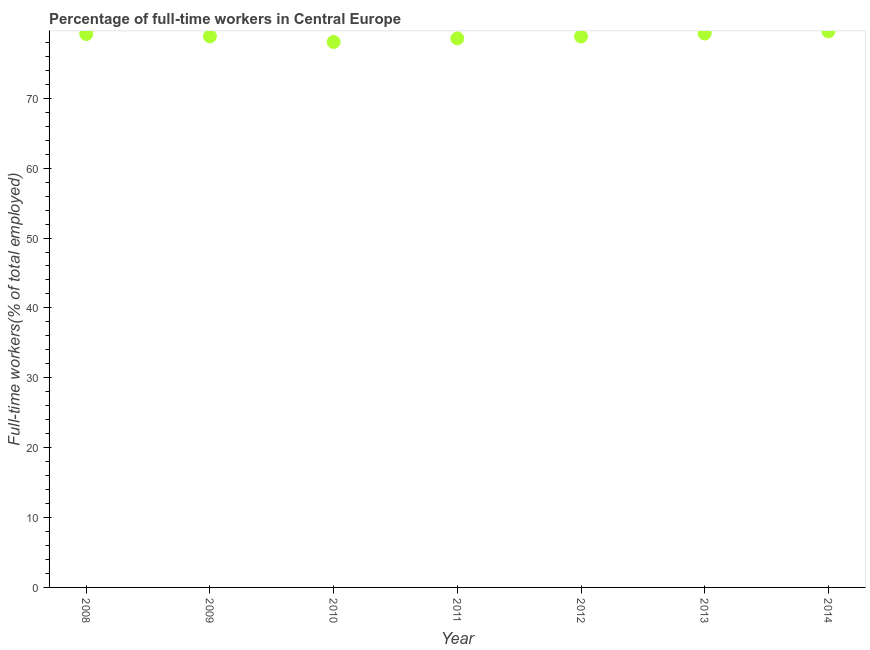What is the percentage of full-time workers in 2008?
Offer a terse response. 79.2. Across all years, what is the maximum percentage of full-time workers?
Your response must be concise. 79.58. Across all years, what is the minimum percentage of full-time workers?
Provide a succinct answer. 78.06. In which year was the percentage of full-time workers maximum?
Provide a succinct answer. 2014. In which year was the percentage of full-time workers minimum?
Your response must be concise. 2010. What is the sum of the percentage of full-time workers?
Ensure brevity in your answer.  552.38. What is the difference between the percentage of full-time workers in 2008 and 2011?
Offer a very short reply. 0.62. What is the average percentage of full-time workers per year?
Provide a short and direct response. 78.91. What is the median percentage of full-time workers?
Offer a terse response. 78.86. In how many years, is the percentage of full-time workers greater than 50 %?
Offer a very short reply. 7. Do a majority of the years between 2011 and 2014 (inclusive) have percentage of full-time workers greater than 74 %?
Offer a terse response. Yes. What is the ratio of the percentage of full-time workers in 2009 to that in 2012?
Provide a short and direct response. 1. Is the difference between the percentage of full-time workers in 2011 and 2012 greater than the difference between any two years?
Offer a terse response. No. What is the difference between the highest and the second highest percentage of full-time workers?
Your answer should be very brief. 0.31. Is the sum of the percentage of full-time workers in 2008 and 2014 greater than the maximum percentage of full-time workers across all years?
Provide a succinct answer. Yes. What is the difference between the highest and the lowest percentage of full-time workers?
Your response must be concise. 1.52. Does the percentage of full-time workers monotonically increase over the years?
Ensure brevity in your answer.  No. What is the difference between two consecutive major ticks on the Y-axis?
Give a very brief answer. 10. Are the values on the major ticks of Y-axis written in scientific E-notation?
Make the answer very short. No. Does the graph contain any zero values?
Provide a succinct answer. No. Does the graph contain grids?
Ensure brevity in your answer.  No. What is the title of the graph?
Provide a succinct answer. Percentage of full-time workers in Central Europe. What is the label or title of the Y-axis?
Ensure brevity in your answer.  Full-time workers(% of total employed). What is the Full-time workers(% of total employed) in 2008?
Your answer should be compact. 79.2. What is the Full-time workers(% of total employed) in 2009?
Provide a succinct answer. 78.86. What is the Full-time workers(% of total employed) in 2010?
Provide a short and direct response. 78.06. What is the Full-time workers(% of total employed) in 2011?
Your answer should be compact. 78.58. What is the Full-time workers(% of total employed) in 2012?
Ensure brevity in your answer.  78.84. What is the Full-time workers(% of total employed) in 2013?
Make the answer very short. 79.27. What is the Full-time workers(% of total employed) in 2014?
Make the answer very short. 79.58. What is the difference between the Full-time workers(% of total employed) in 2008 and 2009?
Provide a succinct answer. 0.34. What is the difference between the Full-time workers(% of total employed) in 2008 and 2010?
Ensure brevity in your answer.  1.14. What is the difference between the Full-time workers(% of total employed) in 2008 and 2011?
Offer a terse response. 0.62. What is the difference between the Full-time workers(% of total employed) in 2008 and 2012?
Provide a short and direct response. 0.36. What is the difference between the Full-time workers(% of total employed) in 2008 and 2013?
Offer a very short reply. -0.07. What is the difference between the Full-time workers(% of total employed) in 2008 and 2014?
Give a very brief answer. -0.38. What is the difference between the Full-time workers(% of total employed) in 2009 and 2010?
Your response must be concise. 0.8. What is the difference between the Full-time workers(% of total employed) in 2009 and 2011?
Ensure brevity in your answer.  0.28. What is the difference between the Full-time workers(% of total employed) in 2009 and 2012?
Keep it short and to the point. 0.02. What is the difference between the Full-time workers(% of total employed) in 2009 and 2013?
Ensure brevity in your answer.  -0.41. What is the difference between the Full-time workers(% of total employed) in 2009 and 2014?
Keep it short and to the point. -0.72. What is the difference between the Full-time workers(% of total employed) in 2010 and 2011?
Provide a short and direct response. -0.52. What is the difference between the Full-time workers(% of total employed) in 2010 and 2012?
Your answer should be very brief. -0.78. What is the difference between the Full-time workers(% of total employed) in 2010 and 2013?
Your answer should be compact. -1.21. What is the difference between the Full-time workers(% of total employed) in 2010 and 2014?
Make the answer very short. -1.52. What is the difference between the Full-time workers(% of total employed) in 2011 and 2012?
Give a very brief answer. -0.26. What is the difference between the Full-time workers(% of total employed) in 2011 and 2013?
Keep it short and to the point. -0.69. What is the difference between the Full-time workers(% of total employed) in 2011 and 2014?
Provide a succinct answer. -1. What is the difference between the Full-time workers(% of total employed) in 2012 and 2013?
Your answer should be compact. -0.43. What is the difference between the Full-time workers(% of total employed) in 2012 and 2014?
Provide a short and direct response. -0.74. What is the difference between the Full-time workers(% of total employed) in 2013 and 2014?
Your answer should be compact. -0.31. What is the ratio of the Full-time workers(% of total employed) in 2008 to that in 2011?
Provide a succinct answer. 1.01. What is the ratio of the Full-time workers(% of total employed) in 2008 to that in 2013?
Make the answer very short. 1. What is the ratio of the Full-time workers(% of total employed) in 2008 to that in 2014?
Your response must be concise. 0.99. What is the ratio of the Full-time workers(% of total employed) in 2009 to that in 2012?
Offer a very short reply. 1. What is the ratio of the Full-time workers(% of total employed) in 2010 to that in 2011?
Keep it short and to the point. 0.99. What is the ratio of the Full-time workers(% of total employed) in 2010 to that in 2012?
Provide a short and direct response. 0.99. What is the ratio of the Full-time workers(% of total employed) in 2010 to that in 2013?
Offer a terse response. 0.98. What is the ratio of the Full-time workers(% of total employed) in 2011 to that in 2012?
Provide a succinct answer. 1. What is the ratio of the Full-time workers(% of total employed) in 2011 to that in 2013?
Your answer should be compact. 0.99. What is the ratio of the Full-time workers(% of total employed) in 2012 to that in 2013?
Your response must be concise. 0.99. What is the ratio of the Full-time workers(% of total employed) in 2013 to that in 2014?
Provide a succinct answer. 1. 